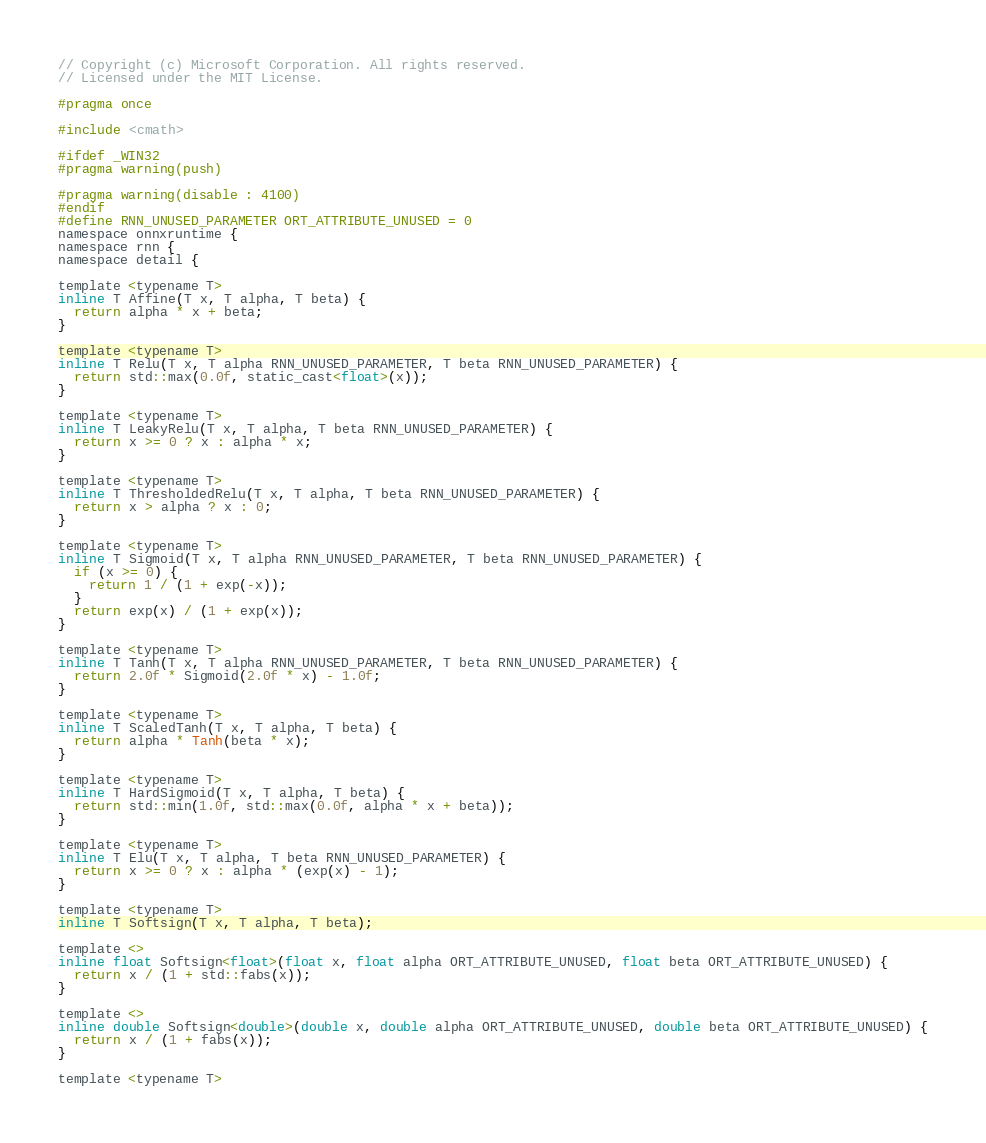<code> <loc_0><loc_0><loc_500><loc_500><_C_>// Copyright (c) Microsoft Corporation. All rights reserved.
// Licensed under the MIT License.

#pragma once

#include <cmath>

#ifdef _WIN32
#pragma warning(push)

#pragma warning(disable : 4100)
#endif
#define RNN_UNUSED_PARAMETER ORT_ATTRIBUTE_UNUSED = 0
namespace onnxruntime {
namespace rnn {
namespace detail {

template <typename T>
inline T Affine(T x, T alpha, T beta) {
  return alpha * x + beta;
}

template <typename T>
inline T Relu(T x, T alpha RNN_UNUSED_PARAMETER, T beta RNN_UNUSED_PARAMETER) {
  return std::max(0.0f, static_cast<float>(x));
}

template <typename T>
inline T LeakyRelu(T x, T alpha, T beta RNN_UNUSED_PARAMETER) {
  return x >= 0 ? x : alpha * x;
}

template <typename T>
inline T ThresholdedRelu(T x, T alpha, T beta RNN_UNUSED_PARAMETER) {
  return x > alpha ? x : 0;
}

template <typename T>
inline T Sigmoid(T x, T alpha RNN_UNUSED_PARAMETER, T beta RNN_UNUSED_PARAMETER) {
  if (x >= 0) {
    return 1 / (1 + exp(-x));
  }
  return exp(x) / (1 + exp(x));
}

template <typename T>
inline T Tanh(T x, T alpha RNN_UNUSED_PARAMETER, T beta RNN_UNUSED_PARAMETER) {
  return 2.0f * Sigmoid(2.0f * x) - 1.0f;
}

template <typename T>
inline T ScaledTanh(T x, T alpha, T beta) {
  return alpha * Tanh(beta * x);
}

template <typename T>
inline T HardSigmoid(T x, T alpha, T beta) {
  return std::min(1.0f, std::max(0.0f, alpha * x + beta));
}

template <typename T>
inline T Elu(T x, T alpha, T beta RNN_UNUSED_PARAMETER) {
  return x >= 0 ? x : alpha * (exp(x) - 1);
}

template <typename T>
inline T Softsign(T x, T alpha, T beta);

template <>
inline float Softsign<float>(float x, float alpha ORT_ATTRIBUTE_UNUSED, float beta ORT_ATTRIBUTE_UNUSED) {
  return x / (1 + std::fabs(x));
}

template <>
inline double Softsign<double>(double x, double alpha ORT_ATTRIBUTE_UNUSED, double beta ORT_ATTRIBUTE_UNUSED) {
  return x / (1 + fabs(x));
}

template <typename T></code> 